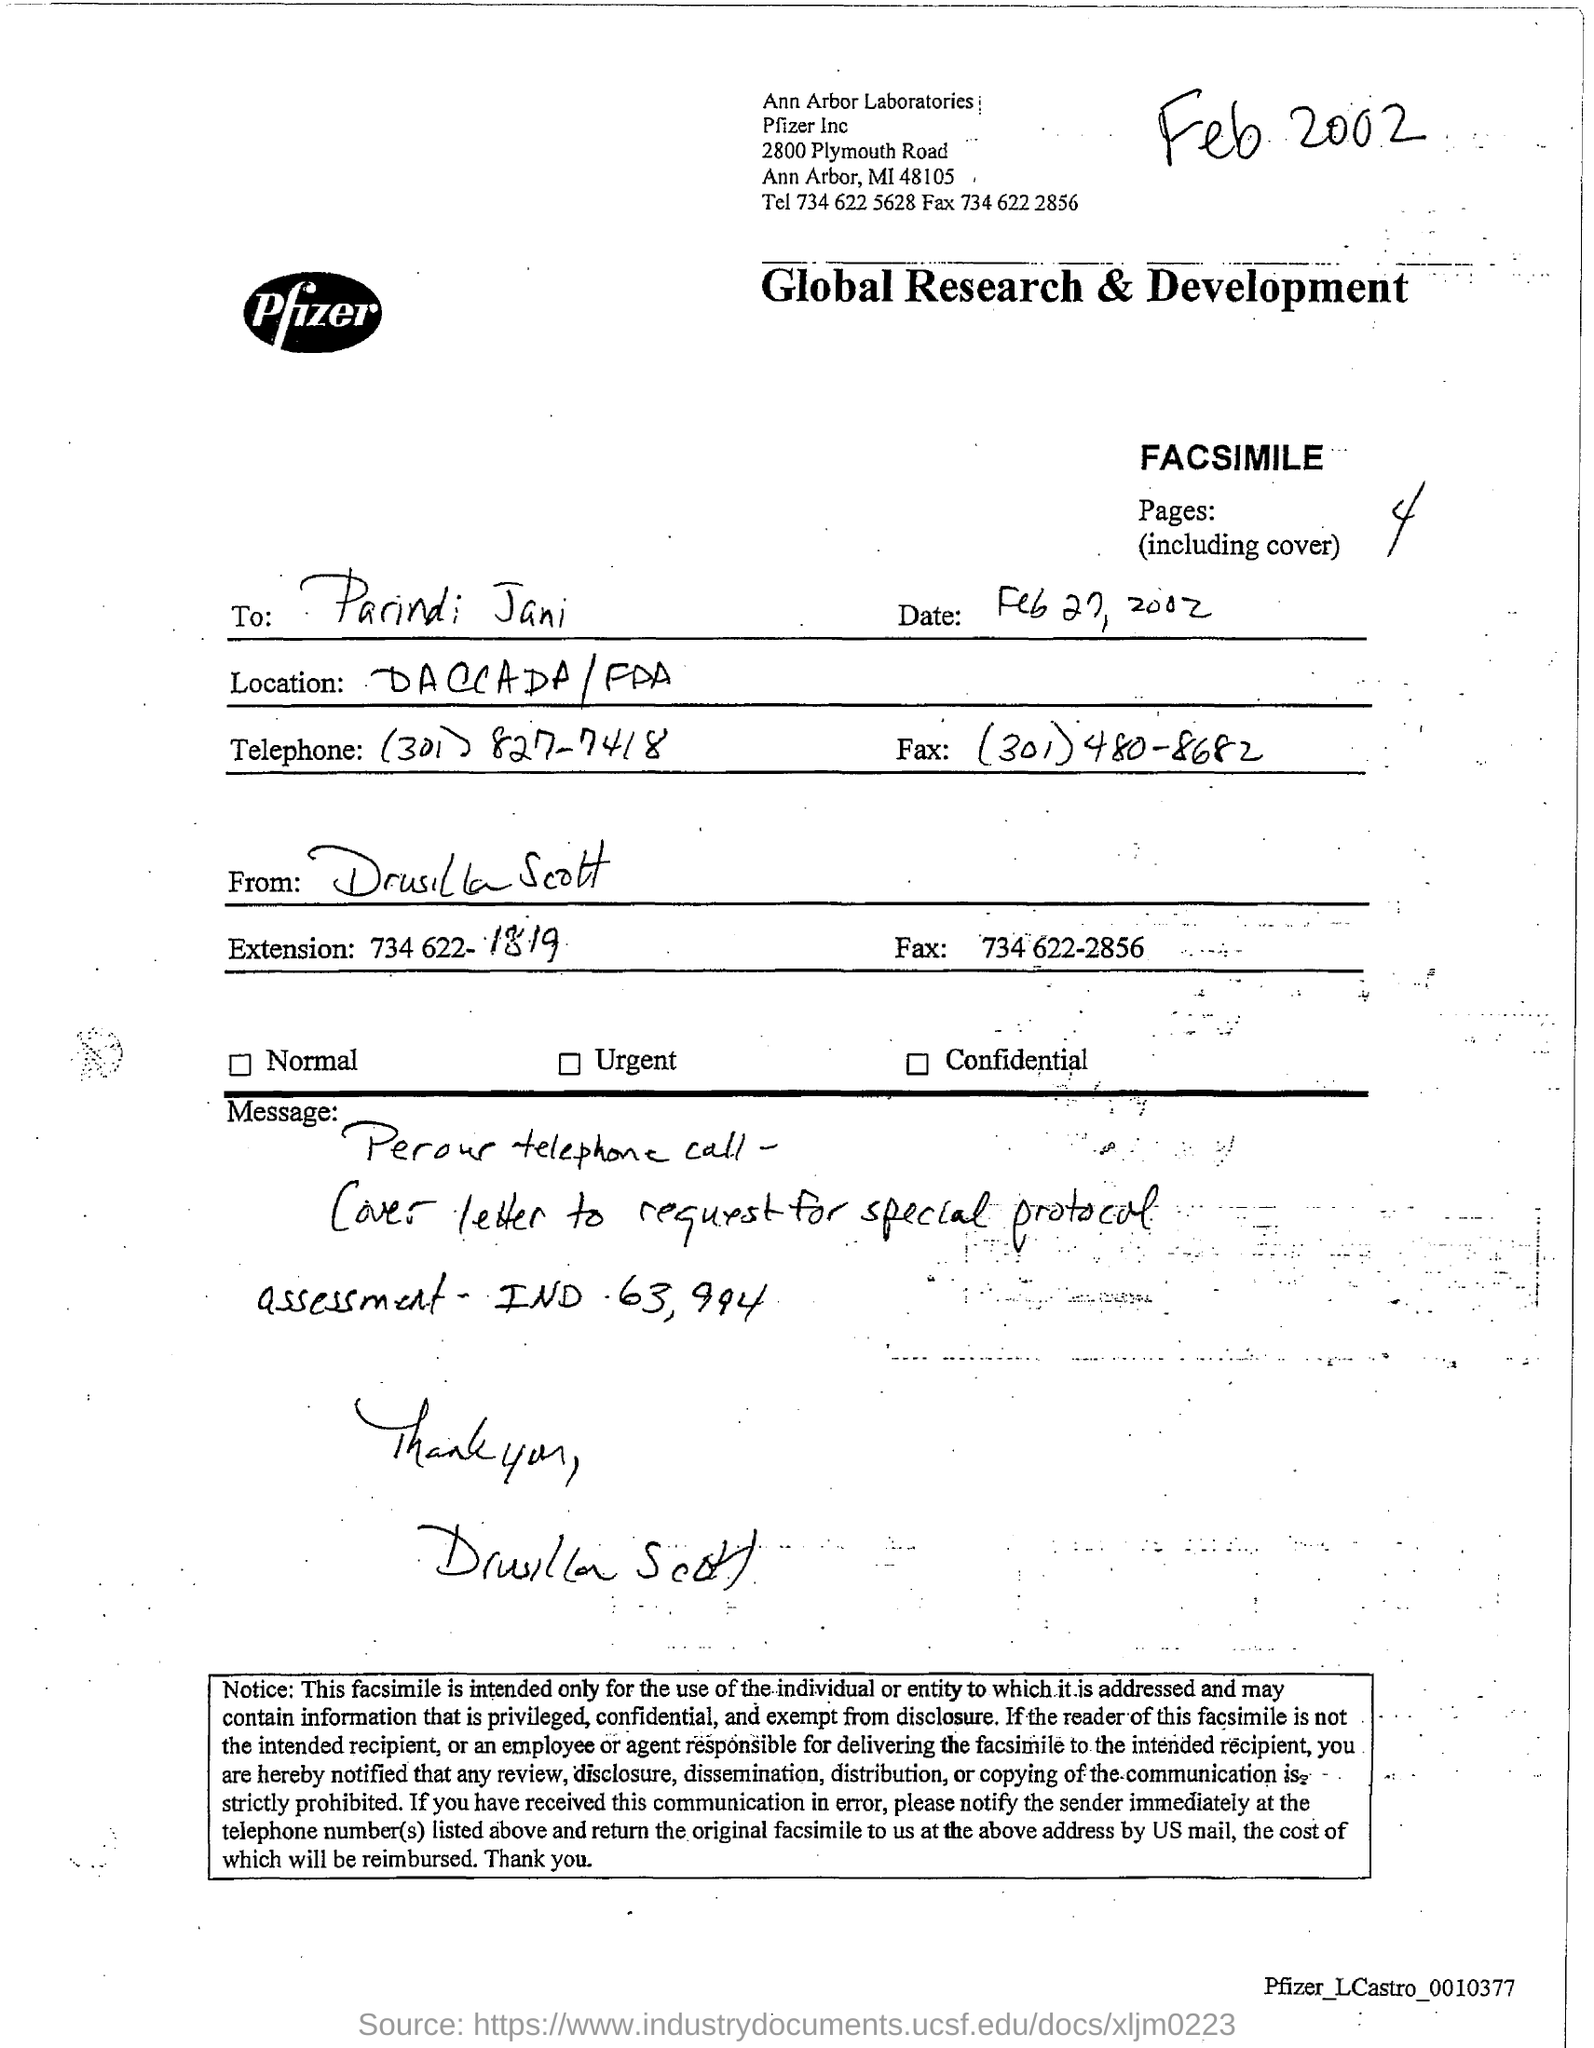How many pages are there in the facsimile including cover?
Provide a succinct answer. 4. Who is the sender of the facsimile?
Give a very brief answer. Drusilla Scott. What is the Fax no of Drusilla Scott given?
Give a very brief answer. 734 622-2856. Who is the receiver of the facsimile?
Give a very brief answer. Parindi Jani. What is the Fax no of Parindi Jani?
Provide a short and direct response. (301)480-8682. 